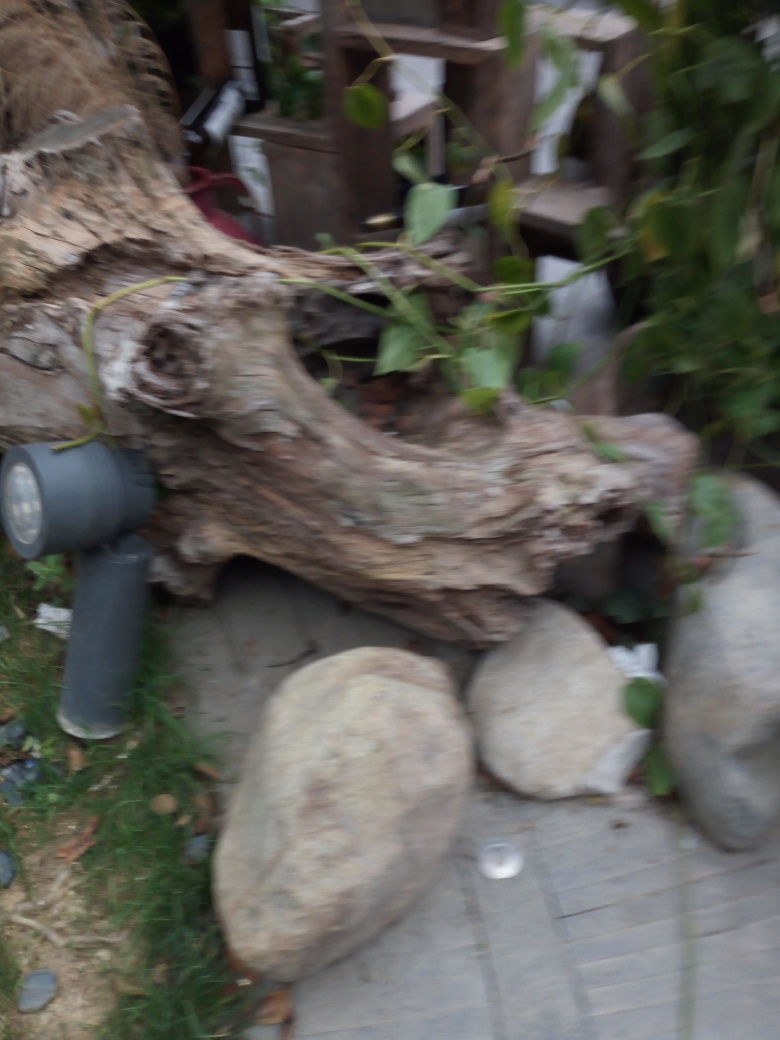What suggestions would you give to improve the quality of an image like this? To enhance the quality of an image such as this one, it would be best to ensure good lighting and use a steady hand or a tripod to avoid motion blur. Additionally, adjusting the camera focus to the main subject of the photo, like the tree stump, can help make the image clearer and more compelling. It's also beneficial to check the camera’s settings to match the environment's light conditions. 